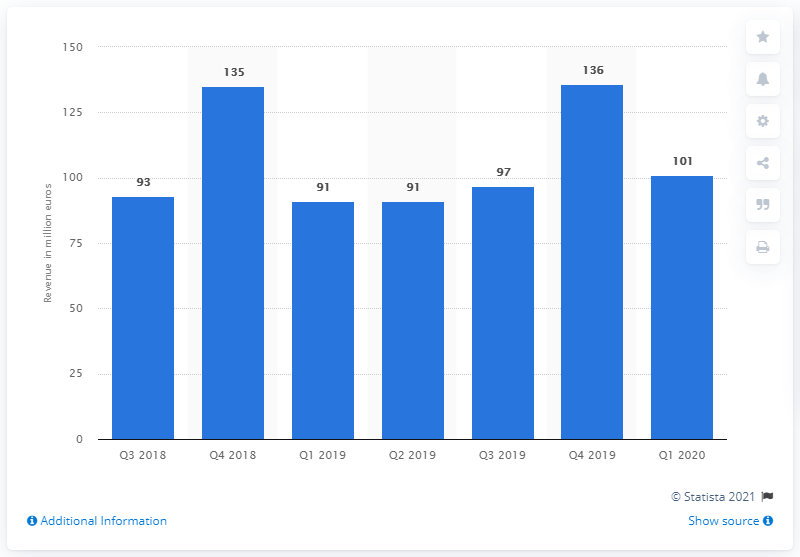List a handful of essential elements in this visual. The revenue of small domestic appliances in the fourth quarter of 2019 was 136. In the first quarter of 2020, small domestic appliances generated $101 million in revenue. 